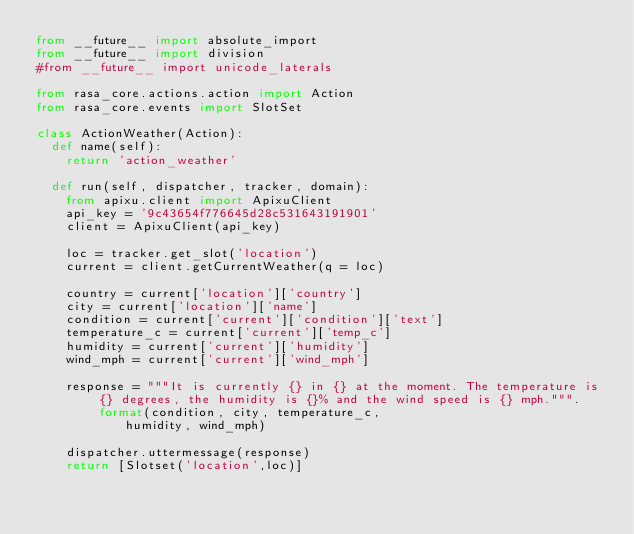<code> <loc_0><loc_0><loc_500><loc_500><_Python_>from __future__ import absolute_import
from __future__ import division
#from __future__ import unicode_laterals

from rasa_core.actions.action import Action
from rasa_core.events import SlotSet

class ActionWeather(Action):
	def name(self):
		return 'action_weather'
	
	def run(self, dispatcher, tracker, domain):
		from apixu.client import ApixuClient
		api_key = '9c43654f776645d28c531643191901'
		client = ApixuClient(api_key)
		
		loc = tracker.get_slot('location')
		current = client.getCurrentWeather(q = loc)
		
		country = current['location']['country']
		city = current['location']['name']
		condition = current['current']['condition']['text']
		temperature_c = current['current']['temp_c']
		humidity = current['current']['humidity']
		wind_mph = current['current']['wind_mph']
		
		response = """It is currently {} in {} at the moment. The temperature is {} degrees, the humidity is {}% and the wind speed is {} mph.""".format(condition, city, temperature_c,
						humidity, wind_mph)
		
		dispatcher.uttermessage(response)
		return [Slotset('location',loc)]</code> 